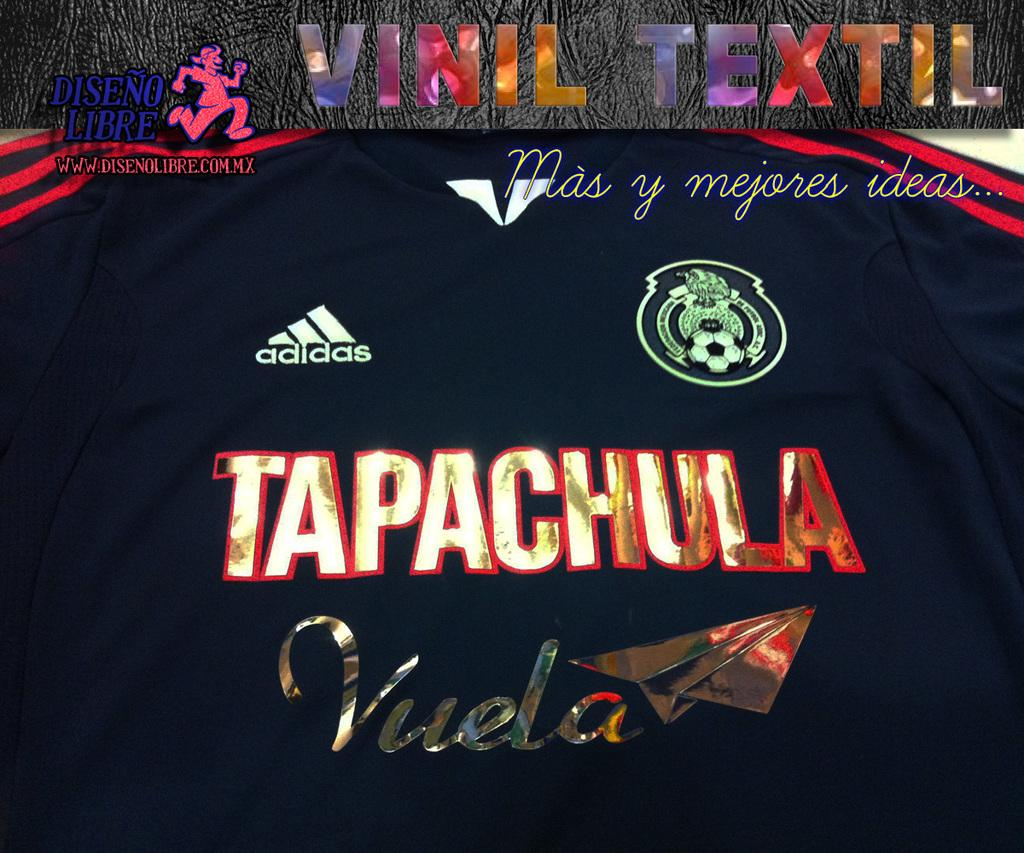Provide a one-sentence caption for the provided image. The event is sponsored by the company Adidas. 